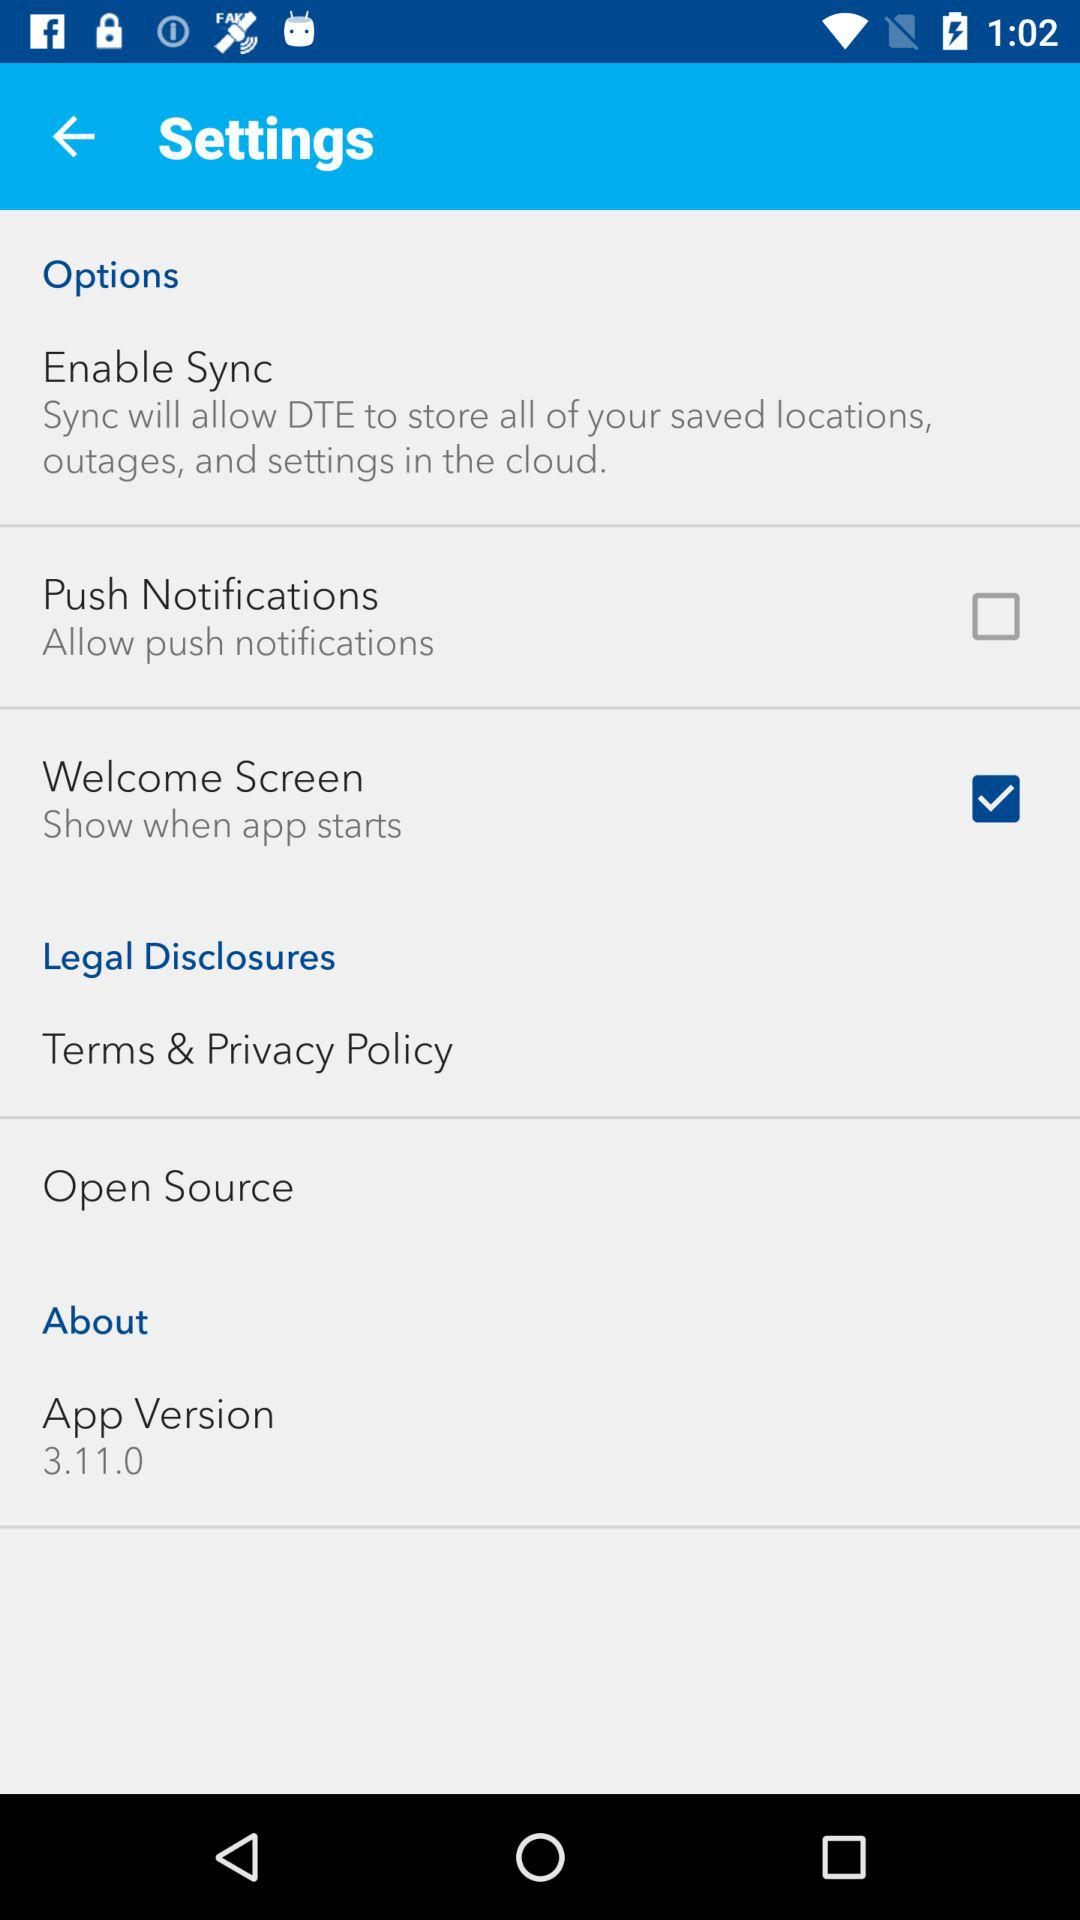What is the app's current version number? The app's current version number is 3.11.0. 